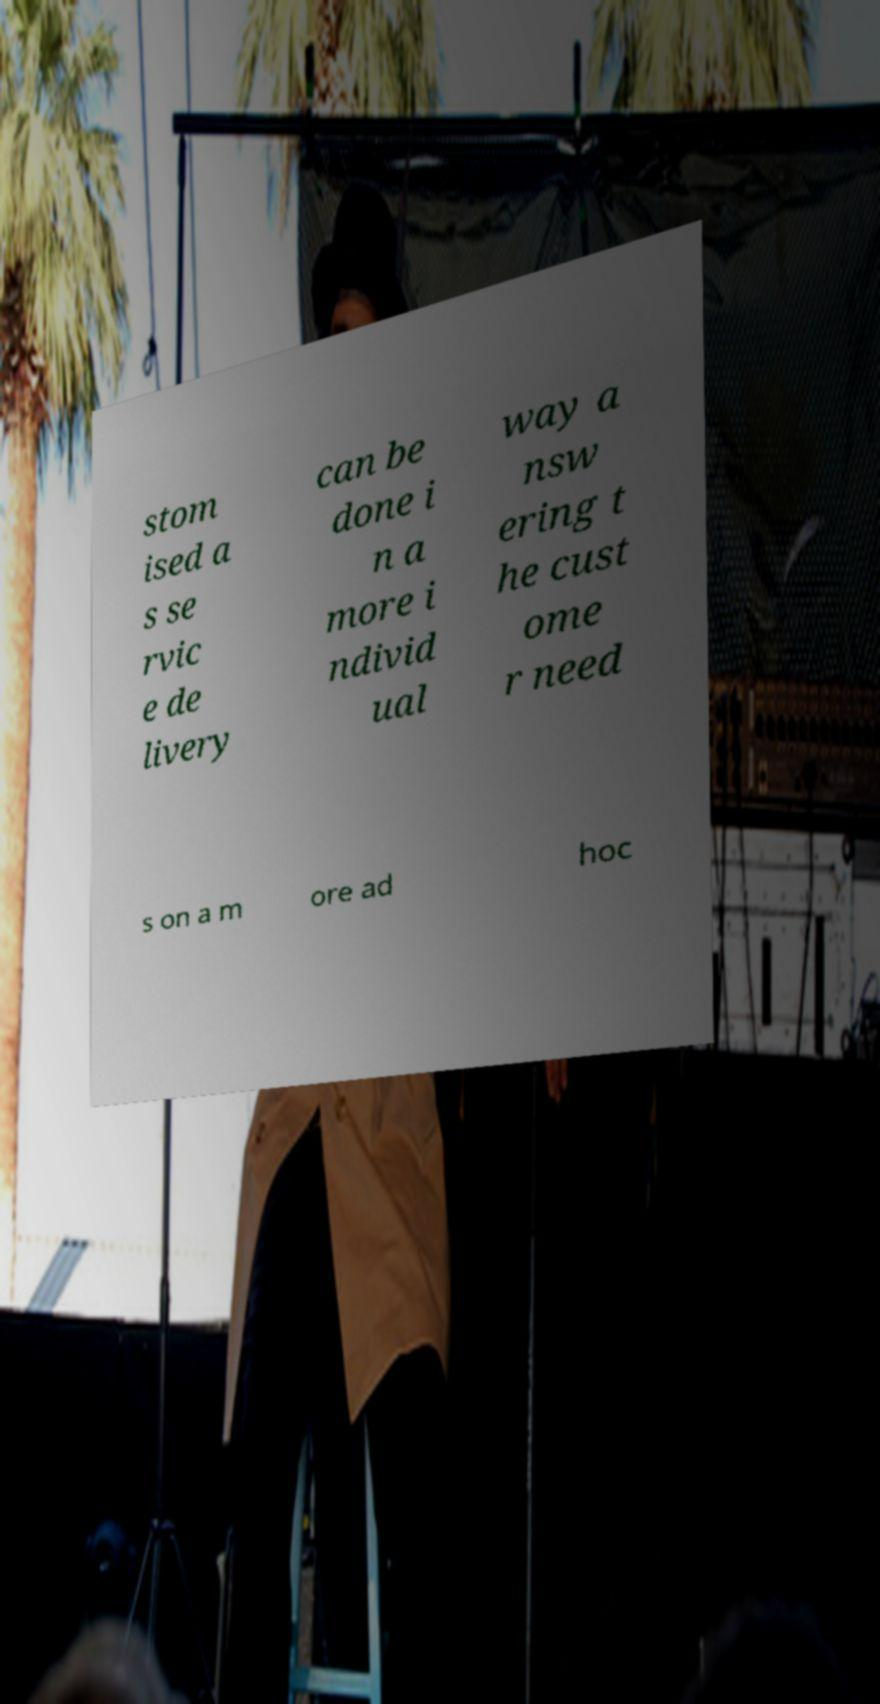Can you accurately transcribe the text from the provided image for me? stom ised a s se rvic e de livery can be done i n a more i ndivid ual way a nsw ering t he cust ome r need s on a m ore ad hoc 